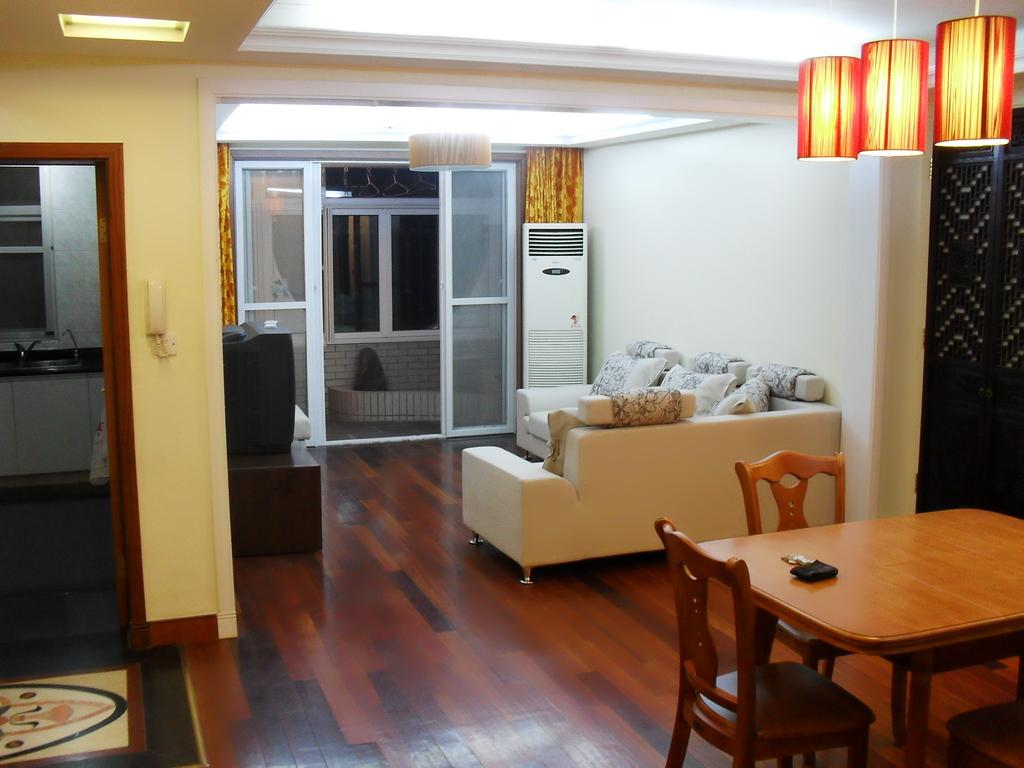What type of space is shown in the image? The image depicts the interior of a room. What furniture is present in the room? There is a table, chairs, and a sofa in the room. What lighting fixtures are in the room? There are lights in the room. What window treatment is present in the room? There are curtains in the room. What electronic device is in the room? There is a television in the room. What appliance is present in the room for temperature control? There is an air conditioner in the room. What type of chalk is being used to draw on the wall in the image? There is no chalk or drawing on the wall present in the image. How does the health of the people in the room affect the temperature setting? The image does not provide any information about the health of the people in the room, nor does it suggest any relationship between the health of the people and the temperature control appliance. 